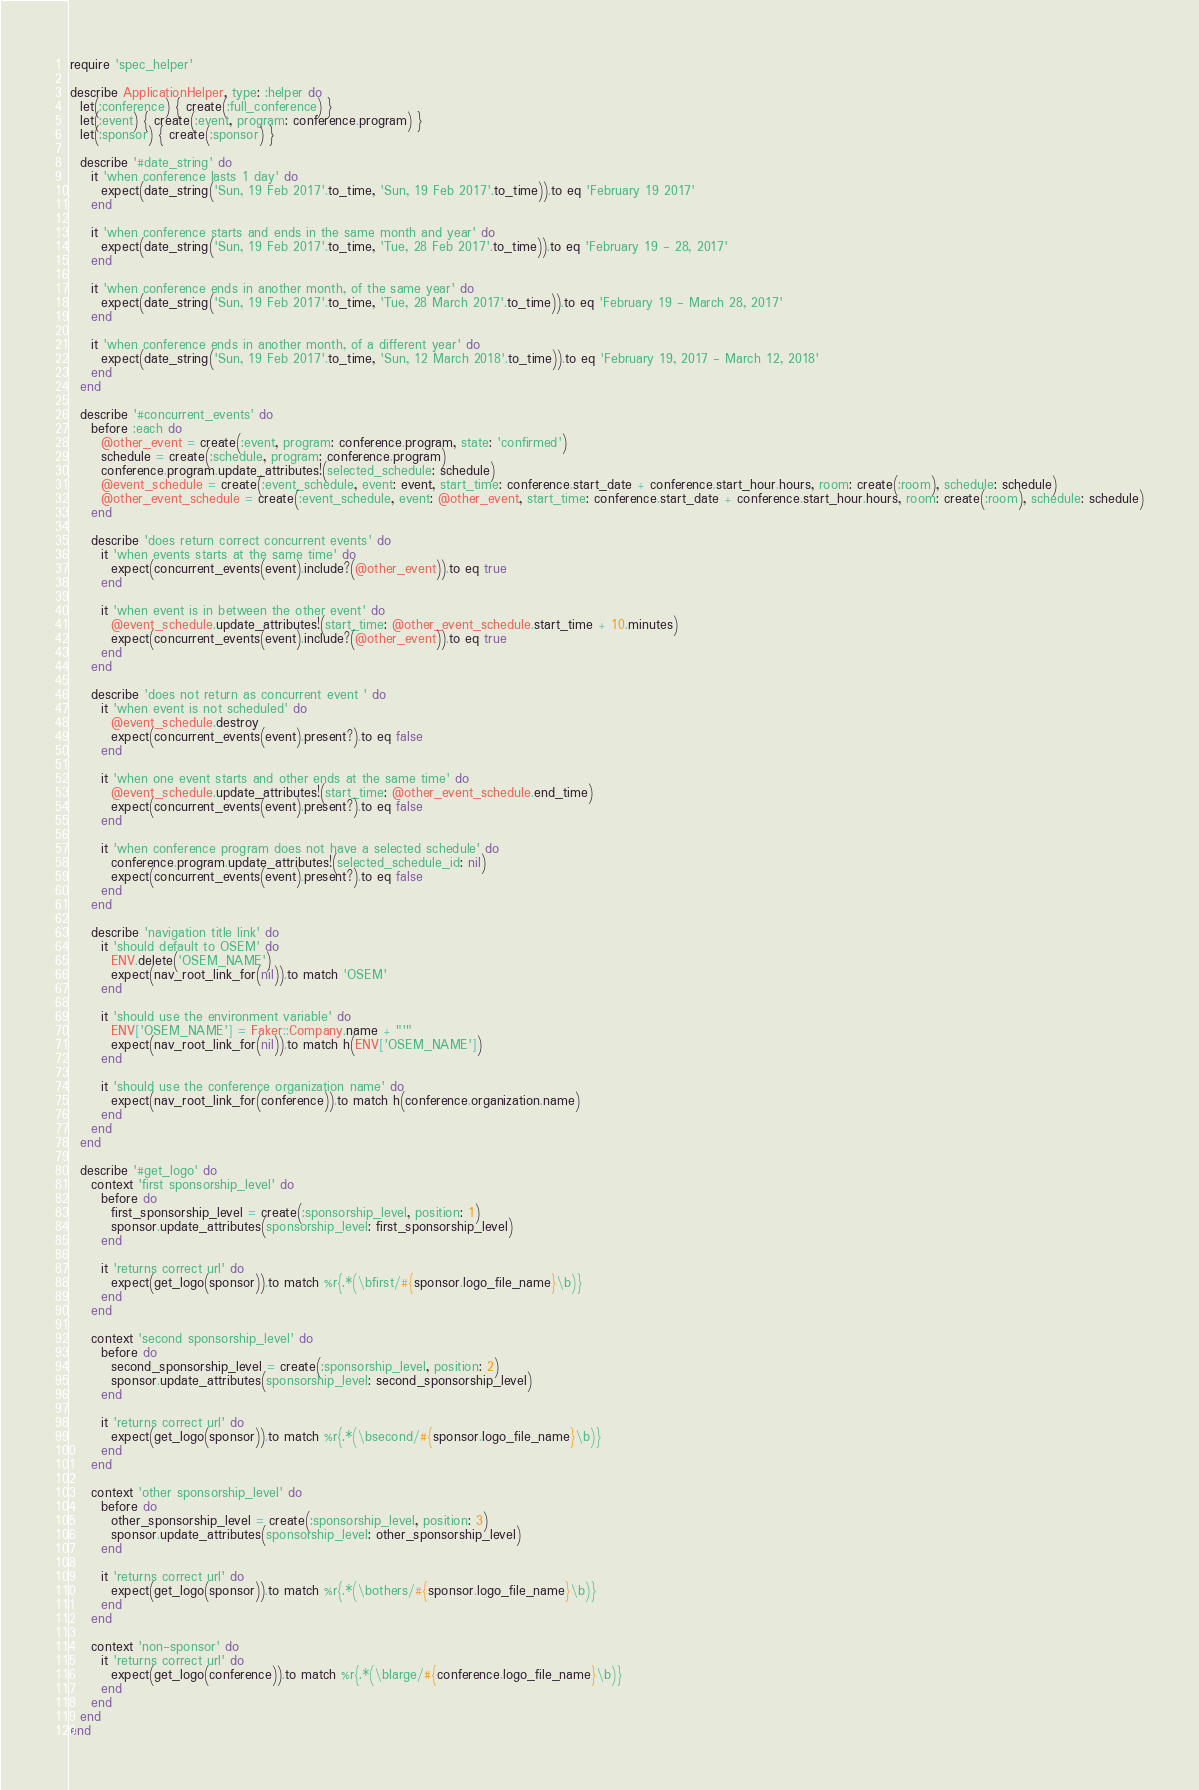Convert code to text. <code><loc_0><loc_0><loc_500><loc_500><_Ruby_>require 'spec_helper'

describe ApplicationHelper, type: :helper do
  let(:conference) { create(:full_conference) }
  let(:event) { create(:event, program: conference.program) }
  let(:sponsor) { create(:sponsor) }

  describe '#date_string' do
    it 'when conference lasts 1 day' do
      expect(date_string('Sun, 19 Feb 2017'.to_time, 'Sun, 19 Feb 2017'.to_time)).to eq 'February 19 2017'
    end

    it 'when conference starts and ends in the same month and year' do
      expect(date_string('Sun, 19 Feb 2017'.to_time, 'Tue, 28 Feb 2017'.to_time)).to eq 'February 19 - 28, 2017'
    end

    it 'when conference ends in another month, of the same year' do
      expect(date_string('Sun, 19 Feb 2017'.to_time, 'Tue, 28 March 2017'.to_time)).to eq 'February 19 - March 28, 2017'
    end

    it 'when conference ends in another month, of a different year' do
      expect(date_string('Sun, 19 Feb 2017'.to_time, 'Sun, 12 March 2018'.to_time)).to eq 'February 19, 2017 - March 12, 2018'
    end
  end

  describe '#concurrent_events' do
    before :each do
      @other_event = create(:event, program: conference.program, state: 'confirmed')
      schedule = create(:schedule, program: conference.program)
      conference.program.update_attributes!(selected_schedule: schedule)
      @event_schedule = create(:event_schedule, event: event, start_time: conference.start_date + conference.start_hour.hours, room: create(:room), schedule: schedule)
      @other_event_schedule = create(:event_schedule, event: @other_event, start_time: conference.start_date + conference.start_hour.hours, room: create(:room), schedule: schedule)
    end

    describe 'does return correct concurrent events' do
      it 'when events starts at the same time' do
        expect(concurrent_events(event).include?(@other_event)).to eq true
      end

      it 'when event is in between the other event' do
        @event_schedule.update_attributes!(start_time: @other_event_schedule.start_time + 10.minutes)
        expect(concurrent_events(event).include?(@other_event)).to eq true
      end
    end

    describe 'does not return as concurrent event ' do
      it 'when event is not scheduled' do
        @event_schedule.destroy
        expect(concurrent_events(event).present?).to eq false
      end

      it 'when one event starts and other ends at the same time' do
        @event_schedule.update_attributes!(start_time: @other_event_schedule.end_time)
        expect(concurrent_events(event).present?).to eq false
      end

      it 'when conference program does not have a selected schedule' do
        conference.program.update_attributes!(selected_schedule_id: nil)
        expect(concurrent_events(event).present?).to eq false
      end
    end

    describe 'navigation title link' do
      it 'should default to OSEM' do
        ENV.delete('OSEM_NAME')
        expect(nav_root_link_for(nil)).to match 'OSEM'
      end

      it 'should use the environment variable' do
        ENV['OSEM_NAME'] = Faker::Company.name + "'"
        expect(nav_root_link_for(nil)).to match h(ENV['OSEM_NAME'])
      end

      it 'should use the conference organization name' do
        expect(nav_root_link_for(conference)).to match h(conference.organization.name)
      end
    end
  end

  describe '#get_logo' do
    context 'first sponsorship_level' do
      before do
        first_sponsorship_level = create(:sponsorship_level, position: 1)
        sponsor.update_attributes(sponsorship_level: first_sponsorship_level)
      end

      it 'returns correct url' do
        expect(get_logo(sponsor)).to match %r{.*(\bfirst/#{sponsor.logo_file_name}\b)}
      end
    end

    context 'second sponsorship_level' do
      before do
        second_sponsorship_level = create(:sponsorship_level, position: 2)
        sponsor.update_attributes(sponsorship_level: second_sponsorship_level)
      end

      it 'returns correct url' do
        expect(get_logo(sponsor)).to match %r{.*(\bsecond/#{sponsor.logo_file_name}\b)}
      end
    end

    context 'other sponsorship_level' do
      before do
        other_sponsorship_level = create(:sponsorship_level, position: 3)
        sponsor.update_attributes(sponsorship_level: other_sponsorship_level)
      end

      it 'returns correct url' do
        expect(get_logo(sponsor)).to match %r{.*(\bothers/#{sponsor.logo_file_name}\b)}
      end
    end

    context 'non-sponsor' do
      it 'returns correct url' do
        expect(get_logo(conference)).to match %r{.*(\blarge/#{conference.logo_file_name}\b)}
      end
    end
  end
end
</code> 